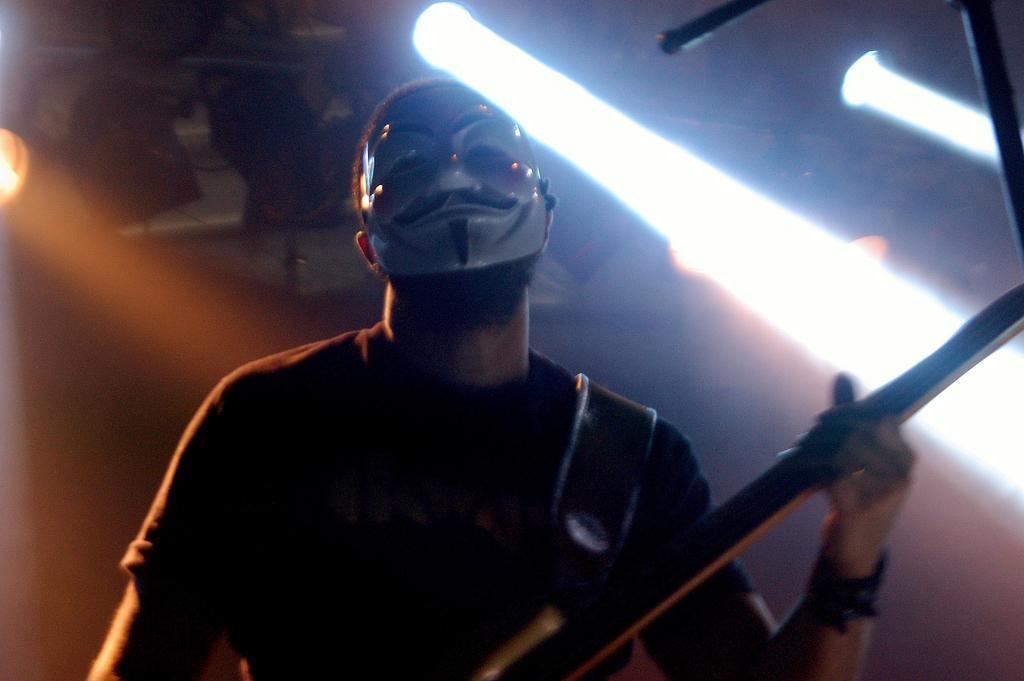Can you describe this image briefly? In this image I can see a person playing a musical instrument. He is wearing a mask. 